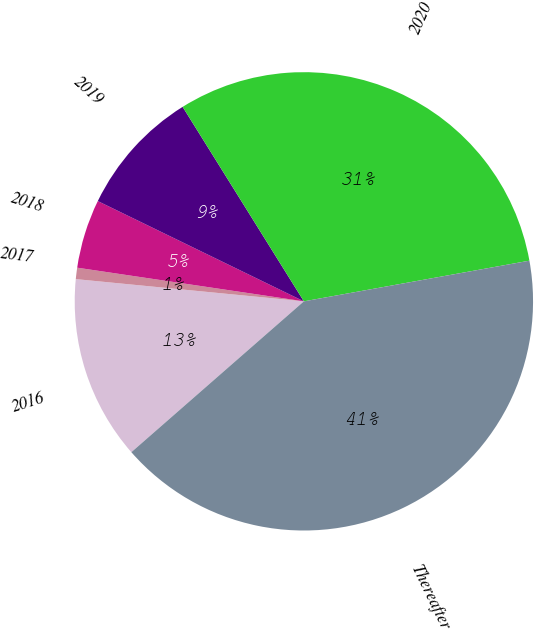Convert chart. <chart><loc_0><loc_0><loc_500><loc_500><pie_chart><fcel>2016<fcel>2017<fcel>2018<fcel>2019<fcel>2020<fcel>Thereafter<nl><fcel>12.98%<fcel>0.8%<fcel>4.86%<fcel>8.92%<fcel>31.03%<fcel>41.4%<nl></chart> 